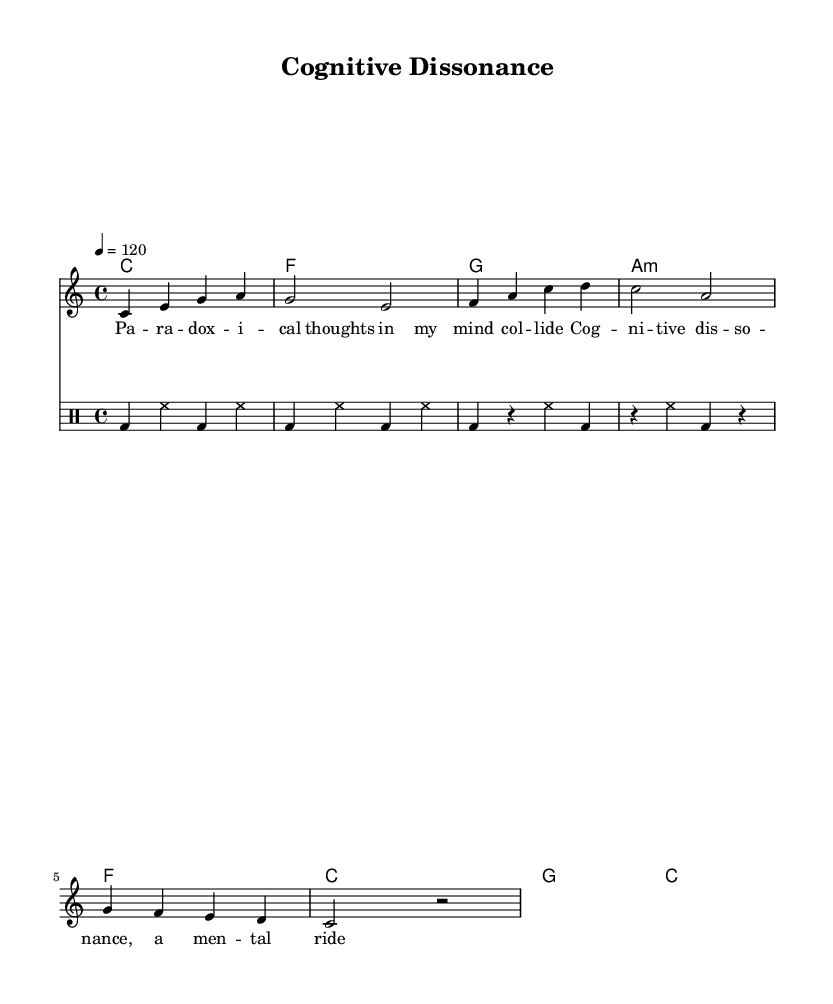What is the key signature of this music? The sheet music shows the key signature at the beginning, which indicates C major, as there are no sharps or flats.
Answer: C major What is the time signature of this music? The time signature is displayed at the beginning of the music, represented as 4/4, meaning there are four beats in each measure.
Answer: 4/4 What is the tempo marking of this music? The tempo is marked as "4 = 120," indicating that there are 120 beats per minute, guiding the speed of the performance.
Answer: 120 How many measures are in the verse? By counting the measures in the verse rhythm, we see four measures are provided before moving to the chorus.
Answer: 4 What type of chords are used in the harmonies section? The harmonies section indicates a mixture of major and minor chords, which is characteristic of pop music, notably containing C major, F major, and A minor.
Answer: Major and minor What lyrical theme is suggested by the title? The title "Cognitive Dissonance" suggests a lyrical exploration of conflicting thoughts and feelings, hinting at an intellectual pop song with deep themes.
Answer: Conflicting thoughts How does the drum rhythm change between the verse and chorus? The verse rhythm consists of a consistent drum pattern, while the chorus introduces rests, creating a dynamic contrast and engaging rhythm throughout the song.
Answer: Consistent to dynamic 